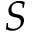<formula> <loc_0><loc_0><loc_500><loc_500>S</formula> 